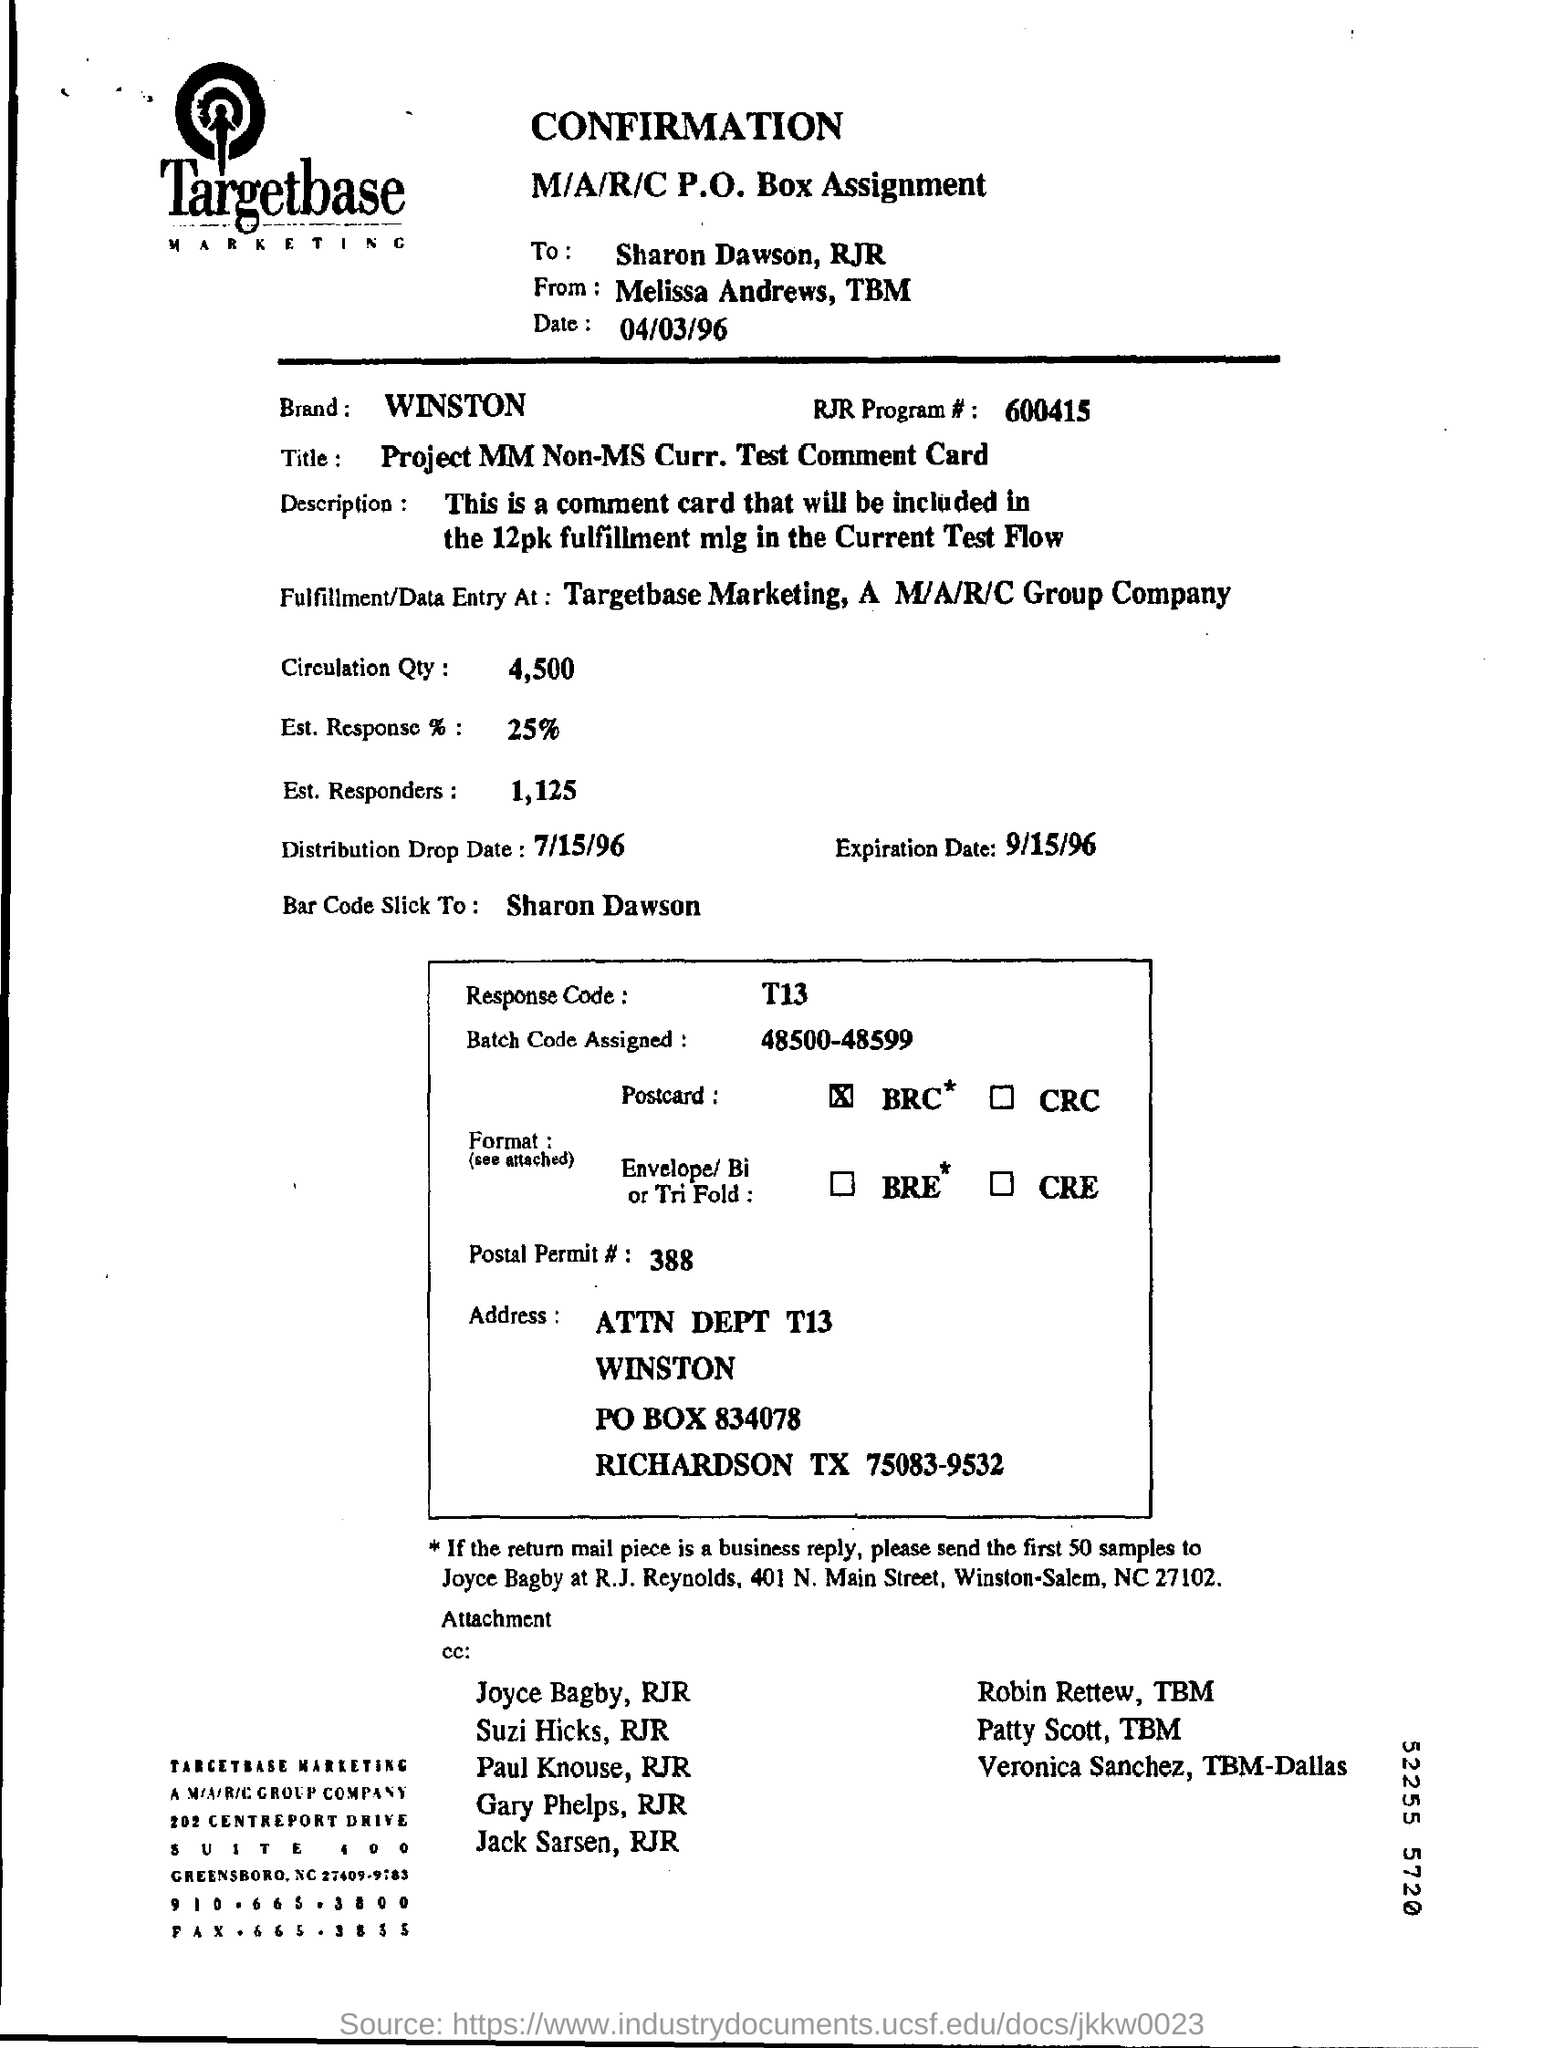Mention a couple of crucial points in this snapshot. The response code is T13. The batch code assigned is 48500-48599. The postal permit is a document that is issued by the relevant authorities and allows a person or organization to engage in specific activities related to the postal service, such as the delivery of mail, packages, or documents. 